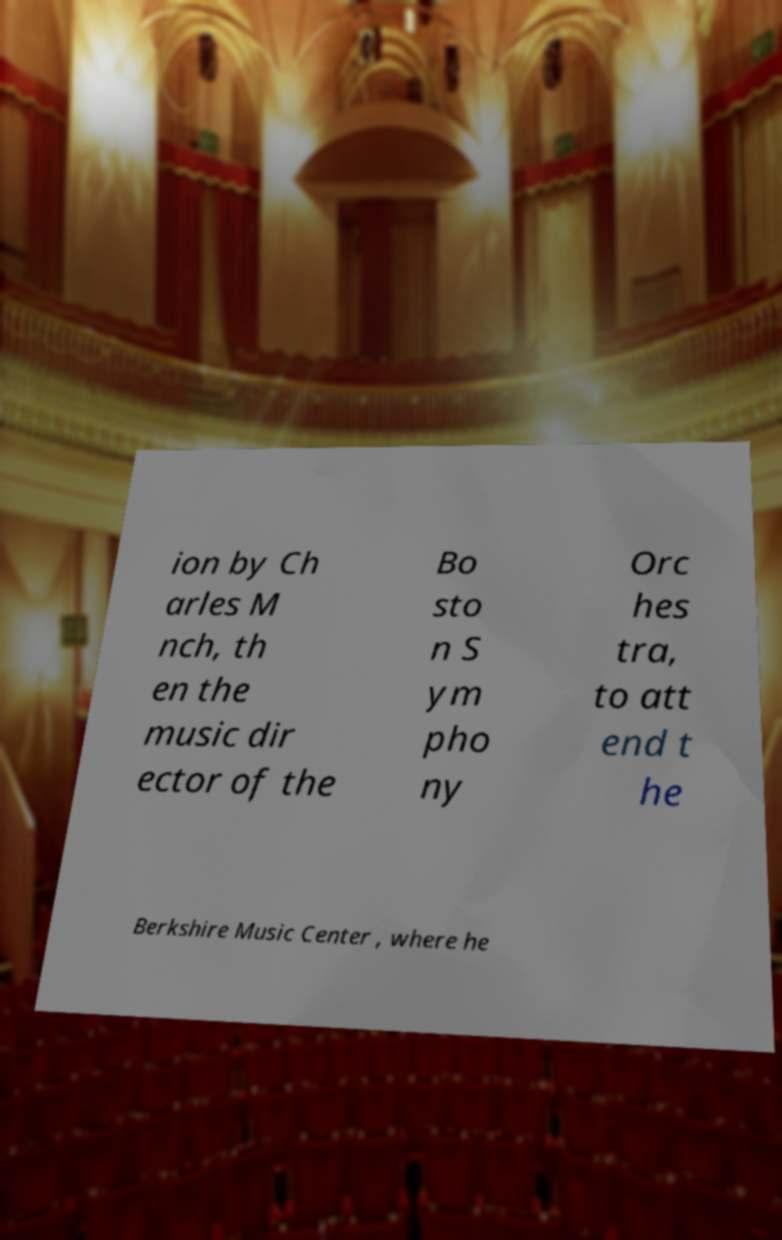Could you extract and type out the text from this image? ion by Ch arles M nch, th en the music dir ector of the Bo sto n S ym pho ny Orc hes tra, to att end t he Berkshire Music Center , where he 